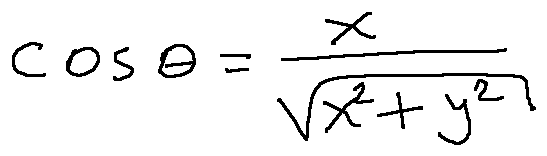Convert formula to latex. <formula><loc_0><loc_0><loc_500><loc_500>\cos \theta = \frac { x } { \sqrt { x ^ { 2 } + y ^ { 2 } } }</formula> 